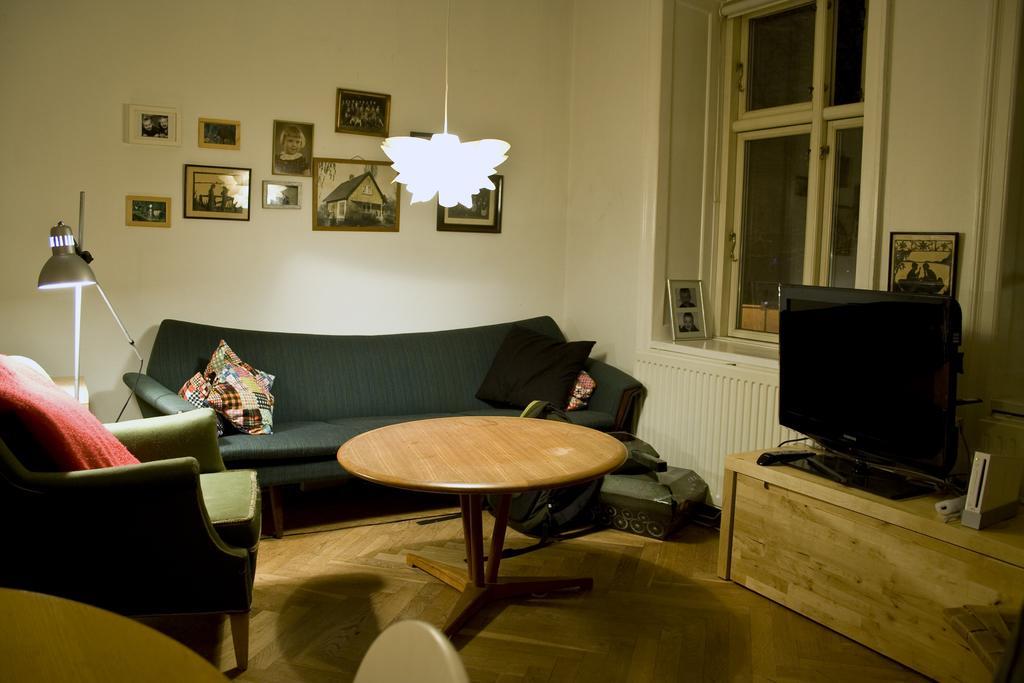Can you describe this image briefly? In a room there is a sofa TV lamp and table with some photo frames on the wall and a chandelier hanging. 